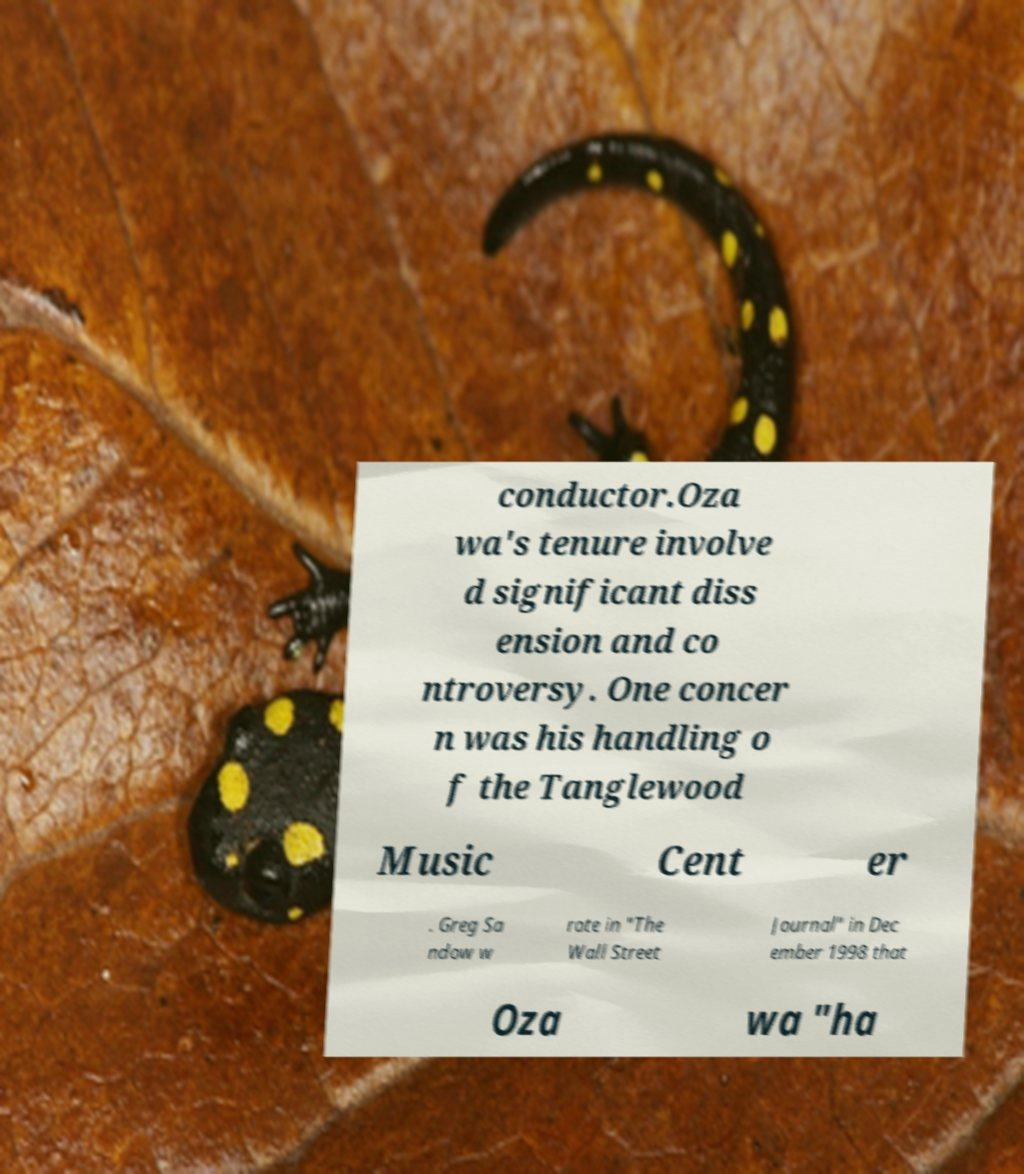Could you assist in decoding the text presented in this image and type it out clearly? conductor.Oza wa's tenure involve d significant diss ension and co ntroversy. One concer n was his handling o f the Tanglewood Music Cent er . Greg Sa ndow w rote in "The Wall Street Journal" in Dec ember 1998 that Oza wa "ha 